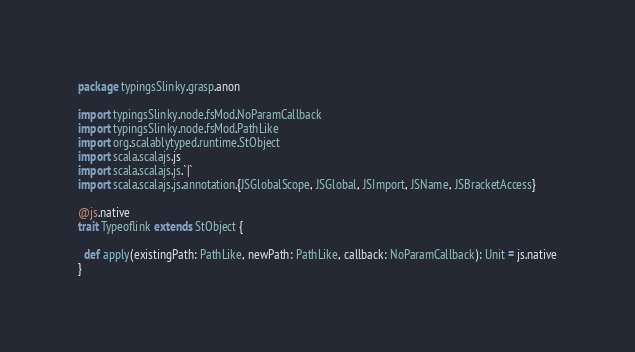Convert code to text. <code><loc_0><loc_0><loc_500><loc_500><_Scala_>package typingsSlinky.grasp.anon

import typingsSlinky.node.fsMod.NoParamCallback
import typingsSlinky.node.fsMod.PathLike
import org.scalablytyped.runtime.StObject
import scala.scalajs.js
import scala.scalajs.js.`|`
import scala.scalajs.js.annotation.{JSGlobalScope, JSGlobal, JSImport, JSName, JSBracketAccess}

@js.native
trait Typeoflink extends StObject {
  
  def apply(existingPath: PathLike, newPath: PathLike, callback: NoParamCallback): Unit = js.native
}
</code> 